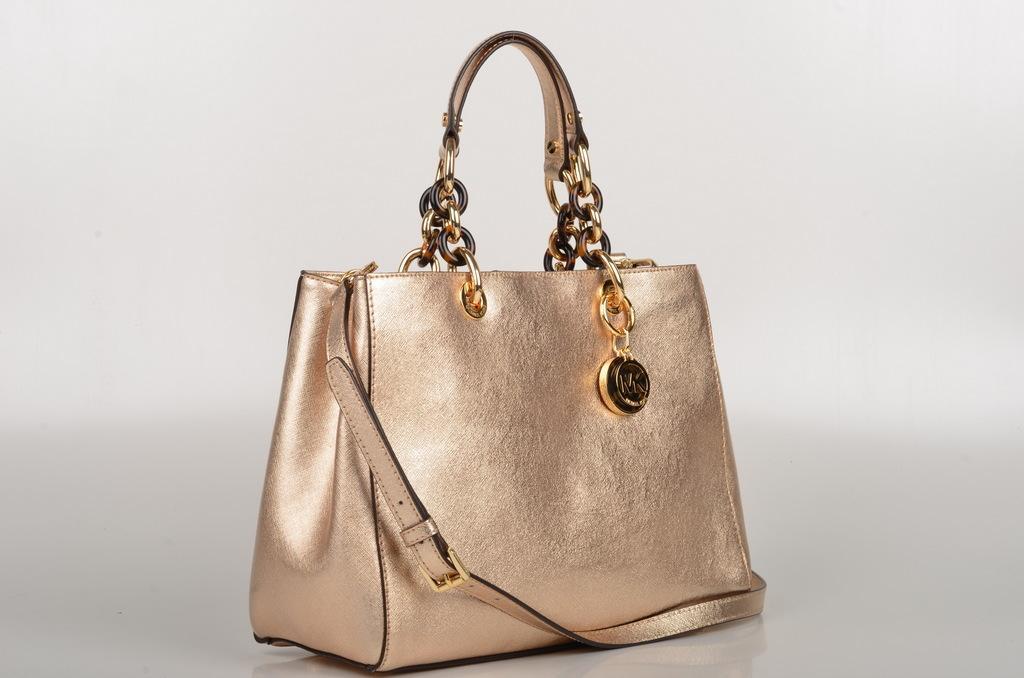Describe this image in one or two sentences. In this picture we can see a golden hand bag on the table. 